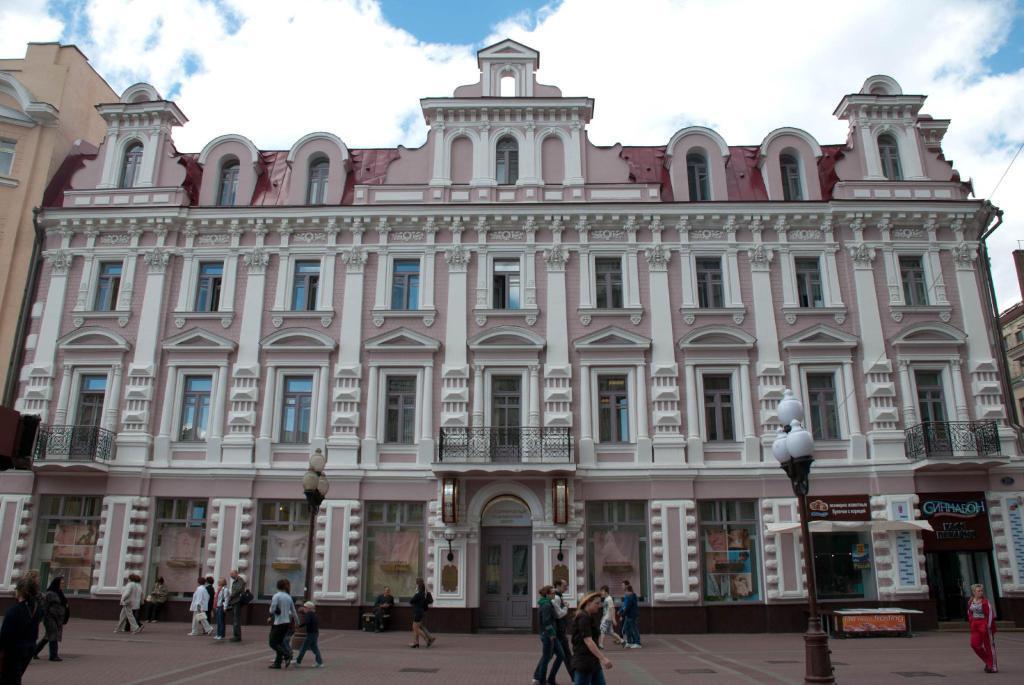In one or two sentences, can you explain what this image depicts? In the center of the image there are buildings. At the bottom there are people walking and we can see poles. At the top there is sky. 